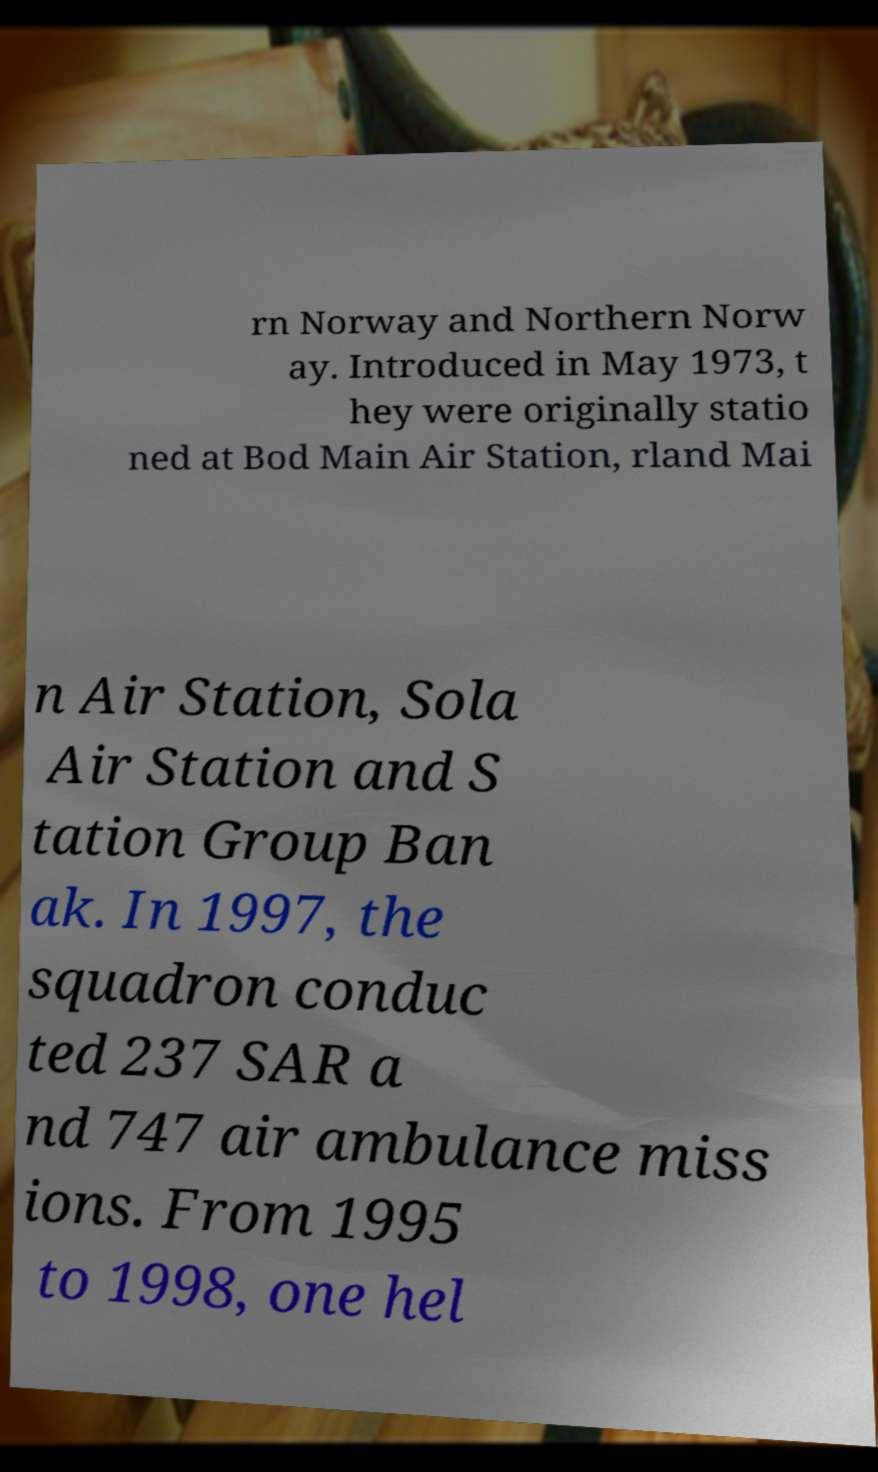I need the written content from this picture converted into text. Can you do that? rn Norway and Northern Norw ay. Introduced in May 1973, t hey were originally statio ned at Bod Main Air Station, rland Mai n Air Station, Sola Air Station and S tation Group Ban ak. In 1997, the squadron conduc ted 237 SAR a nd 747 air ambulance miss ions. From 1995 to 1998, one hel 